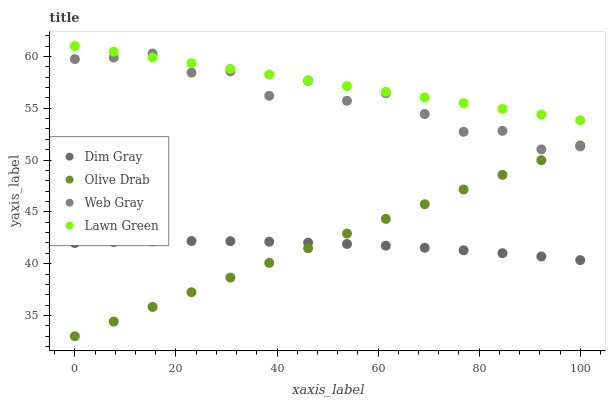Does Dim Gray have the minimum area under the curve?
Answer yes or no. Yes. Does Lawn Green have the maximum area under the curve?
Answer yes or no. Yes. Does Web Gray have the minimum area under the curve?
Answer yes or no. No. Does Web Gray have the maximum area under the curve?
Answer yes or no. No. Is Lawn Green the smoothest?
Answer yes or no. Yes. Is Web Gray the roughest?
Answer yes or no. Yes. Is Dim Gray the smoothest?
Answer yes or no. No. Is Dim Gray the roughest?
Answer yes or no. No. Does Olive Drab have the lowest value?
Answer yes or no. Yes. Does Dim Gray have the lowest value?
Answer yes or no. No. Does Lawn Green have the highest value?
Answer yes or no. Yes. Does Web Gray have the highest value?
Answer yes or no. No. Is Dim Gray less than Web Gray?
Answer yes or no. Yes. Is Web Gray greater than Dim Gray?
Answer yes or no. Yes. Does Web Gray intersect Olive Drab?
Answer yes or no. Yes. Is Web Gray less than Olive Drab?
Answer yes or no. No. Is Web Gray greater than Olive Drab?
Answer yes or no. No. Does Dim Gray intersect Web Gray?
Answer yes or no. No. 